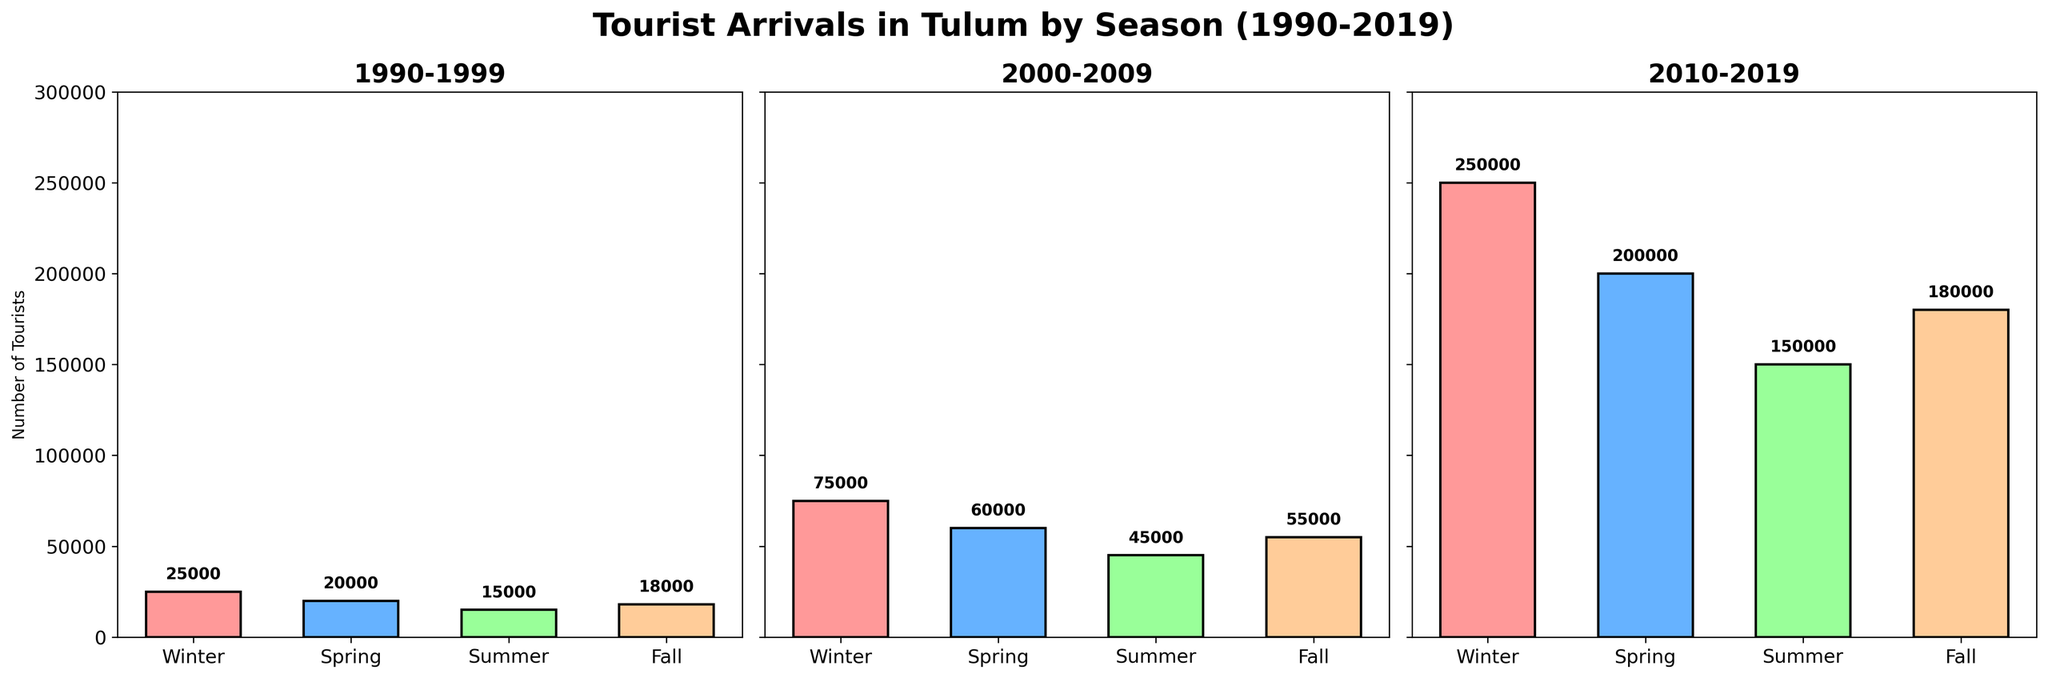What season had the highest number of tourists in the 1990-1999 decade? By looking at the '1990-1999' subplot, the highest bar represents Winter with 25,000 tourists.
Answer: Winter Which decade saw the greatest increase in tourists during the Spring season compared to the previous decade? From the '1990-1999' to '2000-2009', Spring increased by 40,000 (60,000 - 20,000). From '2000-2009' to '2010-2019', Spring increased by 140,000 (200,000 - 60,000). The largest increase happened from '2000-2009' to '2010-2019'.
Answer: 2000-2009 to 2010-2019 How many more tourists visited Tulum in the Summer of 2010-2019 compared to Fall of 1990-1999? Summer of 2010-2019 had 150,000 tourists and Fall of 1990-1999 had 18,000 tourists. The difference is 150,000 - 18,000 = 132,000.
Answer: 132,000 Which season had the lowest number of tourists in each decade shown in the figure? Looking at each subplot: 
1. For '1990-1999', Summer had the lowest with 15,000 tourists.
2. For '2000-2009', Summer had the lowest with 45,000 tourists.
3. For '2010-2019', Summer had the lowest with 150,000 tourists.
Answer: Summer What is the average number of tourists for Fall across the three decades? Sum of Fall tourists across three decades: 18,000 + 55,000 + 180,000 = 253,000. Average is 253,000 / 3 = 84,333.33.
Answer: 84,333.33 Did the Winter season always have the highest number of tourists in each decade? By looking at the figures, in all three decades (1990-1999, 2000-2009, and 2010-2019), Winter had the highest number of tourists.
Answer: Yes Overall, which season showed the most consistent growth over the three decades? By comparing the visual height of the bars in each season's column across decades, Winter shows a consistent and substantial increase in bar height from 25,000 to 75,000 to 250,000.
Answer: Winter What's the average difference in the number of tourists between Winter and Summer across all decades? Differences: 
1. 1990-1999: 25,000 (Winter) - 15,000 (Summer) = 10,000
2. 2000-2009: 75,000 (Winter) - 45,000 (Summer) = 30,000
3. 2010-2019: 250,000 (Winter) - 150,000 (Summer) = 100,000
Sum of differences: 10,000 + 30,000 + 100,000 = 140,000. Average difference = 140,000/3 = 46,666.67.
Answer: 46,666.67 